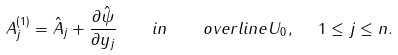Convert formula to latex. <formula><loc_0><loc_0><loc_500><loc_500>A _ { j } ^ { ( 1 ) } = \hat { A } _ { j } + \frac { \partial \hat { \psi } } { \partial y _ { j } } \quad i n \quad o v e r l i n e { U _ { 0 } } , \ \ 1 \leq j \leq n .</formula> 